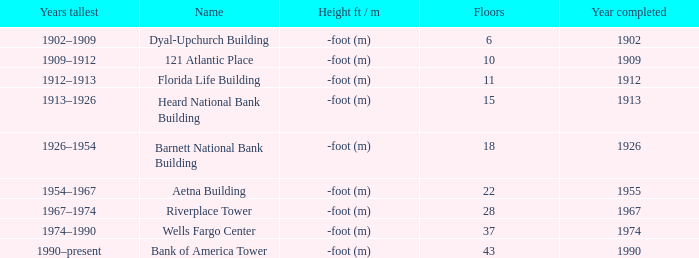When was the construction of the 10-floor building concluded? 1909.0. 